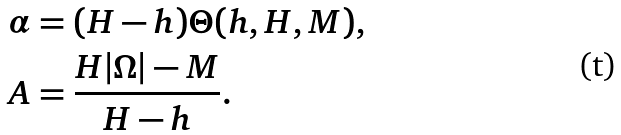<formula> <loc_0><loc_0><loc_500><loc_500>\alpha & = ( H - h ) \Theta ( h , H , M ) , \\ A & = \frac { H | \Omega | - M } { H - h } .</formula> 